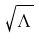<formula> <loc_0><loc_0><loc_500><loc_500>\sqrt { \Lambda }</formula> 